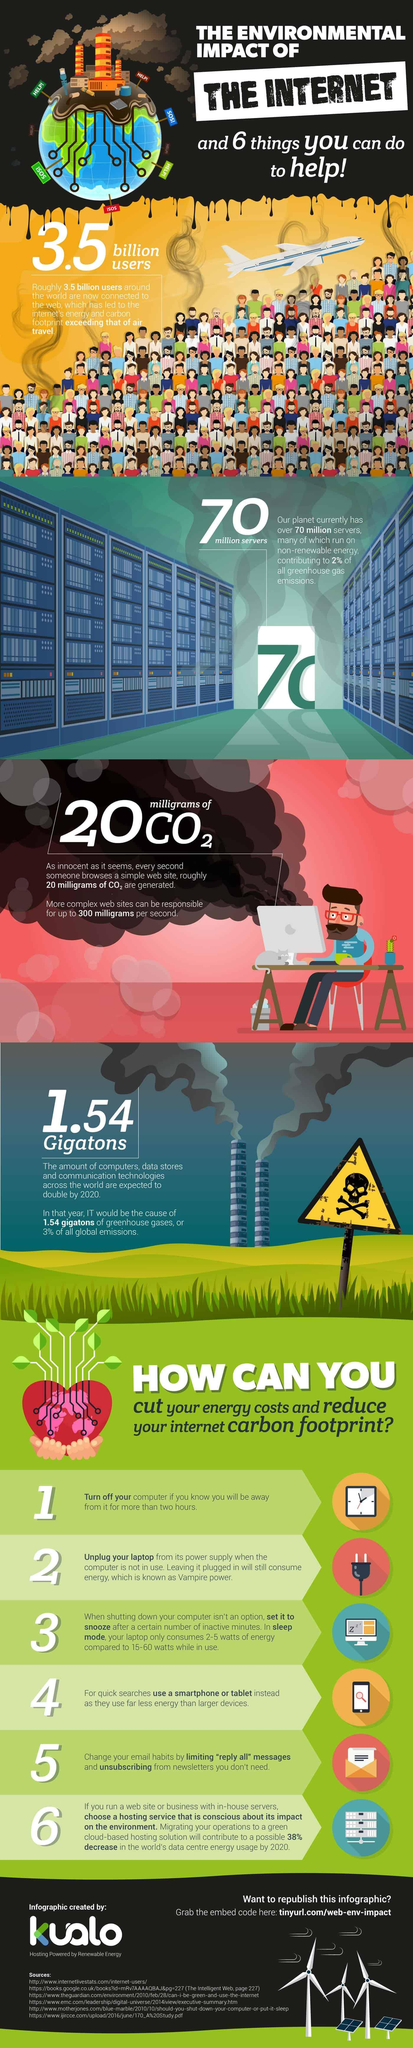Specify some key components in this picture. The number of sources listed at the bottom is six. 